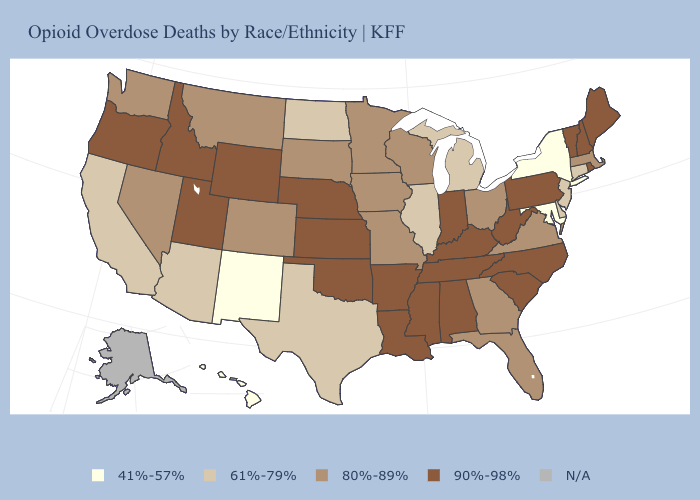What is the highest value in states that border Colorado?
Be succinct. 90%-98%. Name the states that have a value in the range 80%-89%?
Quick response, please. Colorado, Florida, Georgia, Iowa, Massachusetts, Minnesota, Missouri, Montana, Nevada, Ohio, South Dakota, Virginia, Washington, Wisconsin. Name the states that have a value in the range N/A?
Give a very brief answer. Alaska. Name the states that have a value in the range 90%-98%?
Keep it brief. Alabama, Arkansas, Idaho, Indiana, Kansas, Kentucky, Louisiana, Maine, Mississippi, Nebraska, New Hampshire, North Carolina, Oklahoma, Oregon, Pennsylvania, Rhode Island, South Carolina, Tennessee, Utah, Vermont, West Virginia, Wyoming. Name the states that have a value in the range 90%-98%?
Give a very brief answer. Alabama, Arkansas, Idaho, Indiana, Kansas, Kentucky, Louisiana, Maine, Mississippi, Nebraska, New Hampshire, North Carolina, Oklahoma, Oregon, Pennsylvania, Rhode Island, South Carolina, Tennessee, Utah, Vermont, West Virginia, Wyoming. What is the value of Colorado?
Concise answer only. 80%-89%. What is the value of Kentucky?
Quick response, please. 90%-98%. Among the states that border Utah , which have the lowest value?
Keep it brief. New Mexico. Does the first symbol in the legend represent the smallest category?
Write a very short answer. Yes. What is the value of Louisiana?
Concise answer only. 90%-98%. Does Maryland have the lowest value in the South?
Give a very brief answer. Yes. Name the states that have a value in the range N/A?
Give a very brief answer. Alaska. What is the value of Minnesota?
Write a very short answer. 80%-89%. Among the states that border Connecticut , does Massachusetts have the highest value?
Write a very short answer. No. What is the value of New York?
Answer briefly. 41%-57%. 